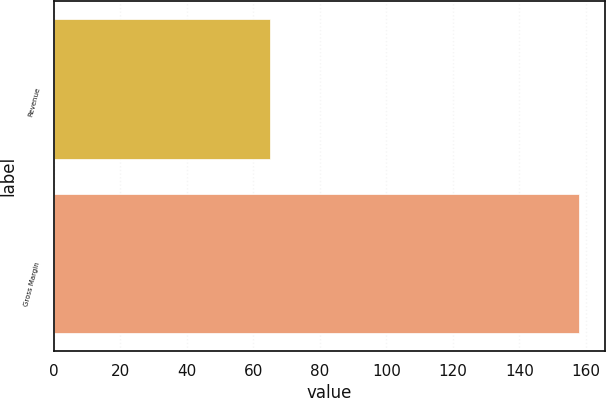Convert chart to OTSL. <chart><loc_0><loc_0><loc_500><loc_500><bar_chart><fcel>Revenue<fcel>Gross Margin<nl><fcel>65<fcel>158<nl></chart> 